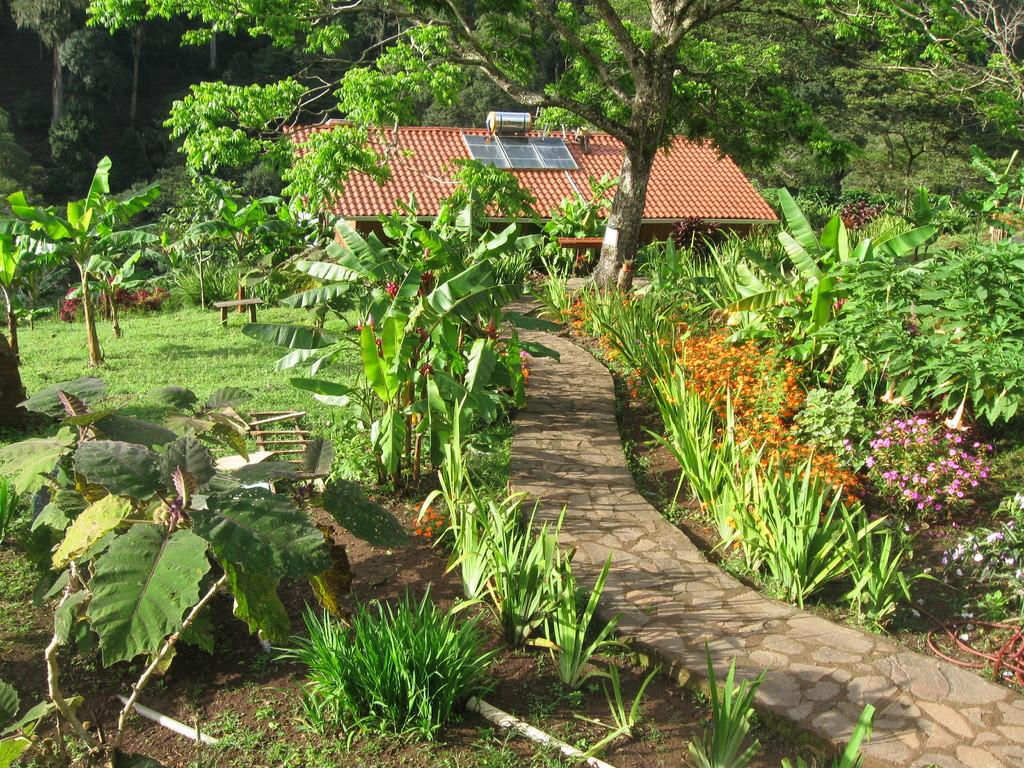What type of living organisms can be seen in the image? Plants and trees are visible in the image. What color are the plants and trees in the image? The plants and trees are green. What type of structure is present in the image? There is a house in the image. What color is the house in the image? The house is brown. What type of beef can be seen hanging from the trees in the image? There is no beef present in the image; it features plants, trees, and a house. What type of skin is visible on the plants in the image? Plants do not have skin; they have leaves and stems. 